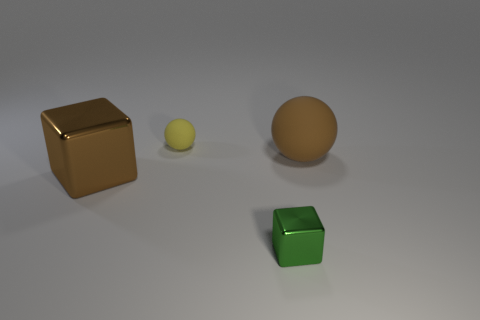There is a big thing that is in front of the brown rubber ball; does it have the same color as the big matte ball?
Offer a terse response. Yes. There is a big sphere; does it have the same color as the metallic cube that is to the left of the yellow thing?
Provide a succinct answer. Yes. Do the brown object in front of the brown matte sphere and the tiny yellow matte thing have the same shape?
Your answer should be compact. No. How big is the metallic cube to the right of the matte sphere that is behind the big rubber object?
Provide a short and direct response. Small. What color is the small thing that is the same material as the brown cube?
Provide a short and direct response. Green. What number of metal cubes have the same size as the brown matte thing?
Ensure brevity in your answer.  1. How many green objects are tiny blocks or matte things?
Ensure brevity in your answer.  1. What number of things are either metallic cubes or metal things in front of the big brown block?
Keep it short and to the point. 2. There is a ball behind the big matte sphere; what material is it?
Keep it short and to the point. Rubber. What shape is the brown matte thing that is the same size as the brown metal thing?
Provide a succinct answer. Sphere. 